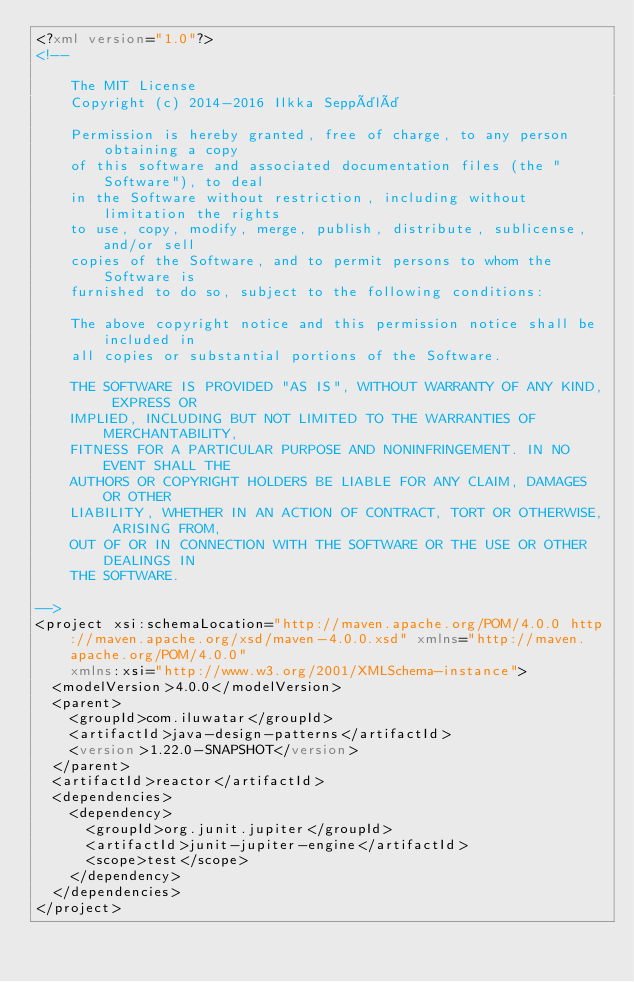<code> <loc_0><loc_0><loc_500><loc_500><_XML_><?xml version="1.0"?>
<!--

    The MIT License
    Copyright (c) 2014-2016 Ilkka Seppälä

    Permission is hereby granted, free of charge, to any person obtaining a copy
    of this software and associated documentation files (the "Software"), to deal
    in the Software without restriction, including without limitation the rights
    to use, copy, modify, merge, publish, distribute, sublicense, and/or sell
    copies of the Software, and to permit persons to whom the Software is
    furnished to do so, subject to the following conditions:

    The above copyright notice and this permission notice shall be included in
    all copies or substantial portions of the Software.

    THE SOFTWARE IS PROVIDED "AS IS", WITHOUT WARRANTY OF ANY KIND, EXPRESS OR
    IMPLIED, INCLUDING BUT NOT LIMITED TO THE WARRANTIES OF MERCHANTABILITY,
    FITNESS FOR A PARTICULAR PURPOSE AND NONINFRINGEMENT. IN NO EVENT SHALL THE
    AUTHORS OR COPYRIGHT HOLDERS BE LIABLE FOR ANY CLAIM, DAMAGES OR OTHER
    LIABILITY, WHETHER IN AN ACTION OF CONTRACT, TORT OR OTHERWISE, ARISING FROM,
    OUT OF OR IN CONNECTION WITH THE SOFTWARE OR THE USE OR OTHER DEALINGS IN
    THE SOFTWARE.

-->
<project xsi:schemaLocation="http://maven.apache.org/POM/4.0.0 http://maven.apache.org/xsd/maven-4.0.0.xsd" xmlns="http://maven.apache.org/POM/4.0.0"
    xmlns:xsi="http://www.w3.org/2001/XMLSchema-instance">
  <modelVersion>4.0.0</modelVersion>
  <parent>
    <groupId>com.iluwatar</groupId>
    <artifactId>java-design-patterns</artifactId>
    <version>1.22.0-SNAPSHOT</version>
  </parent>
  <artifactId>reactor</artifactId>
  <dependencies>
    <dependency>
      <groupId>org.junit.jupiter</groupId>
      <artifactId>junit-jupiter-engine</artifactId>
      <scope>test</scope>
    </dependency>
  </dependencies>
</project>
</code> 